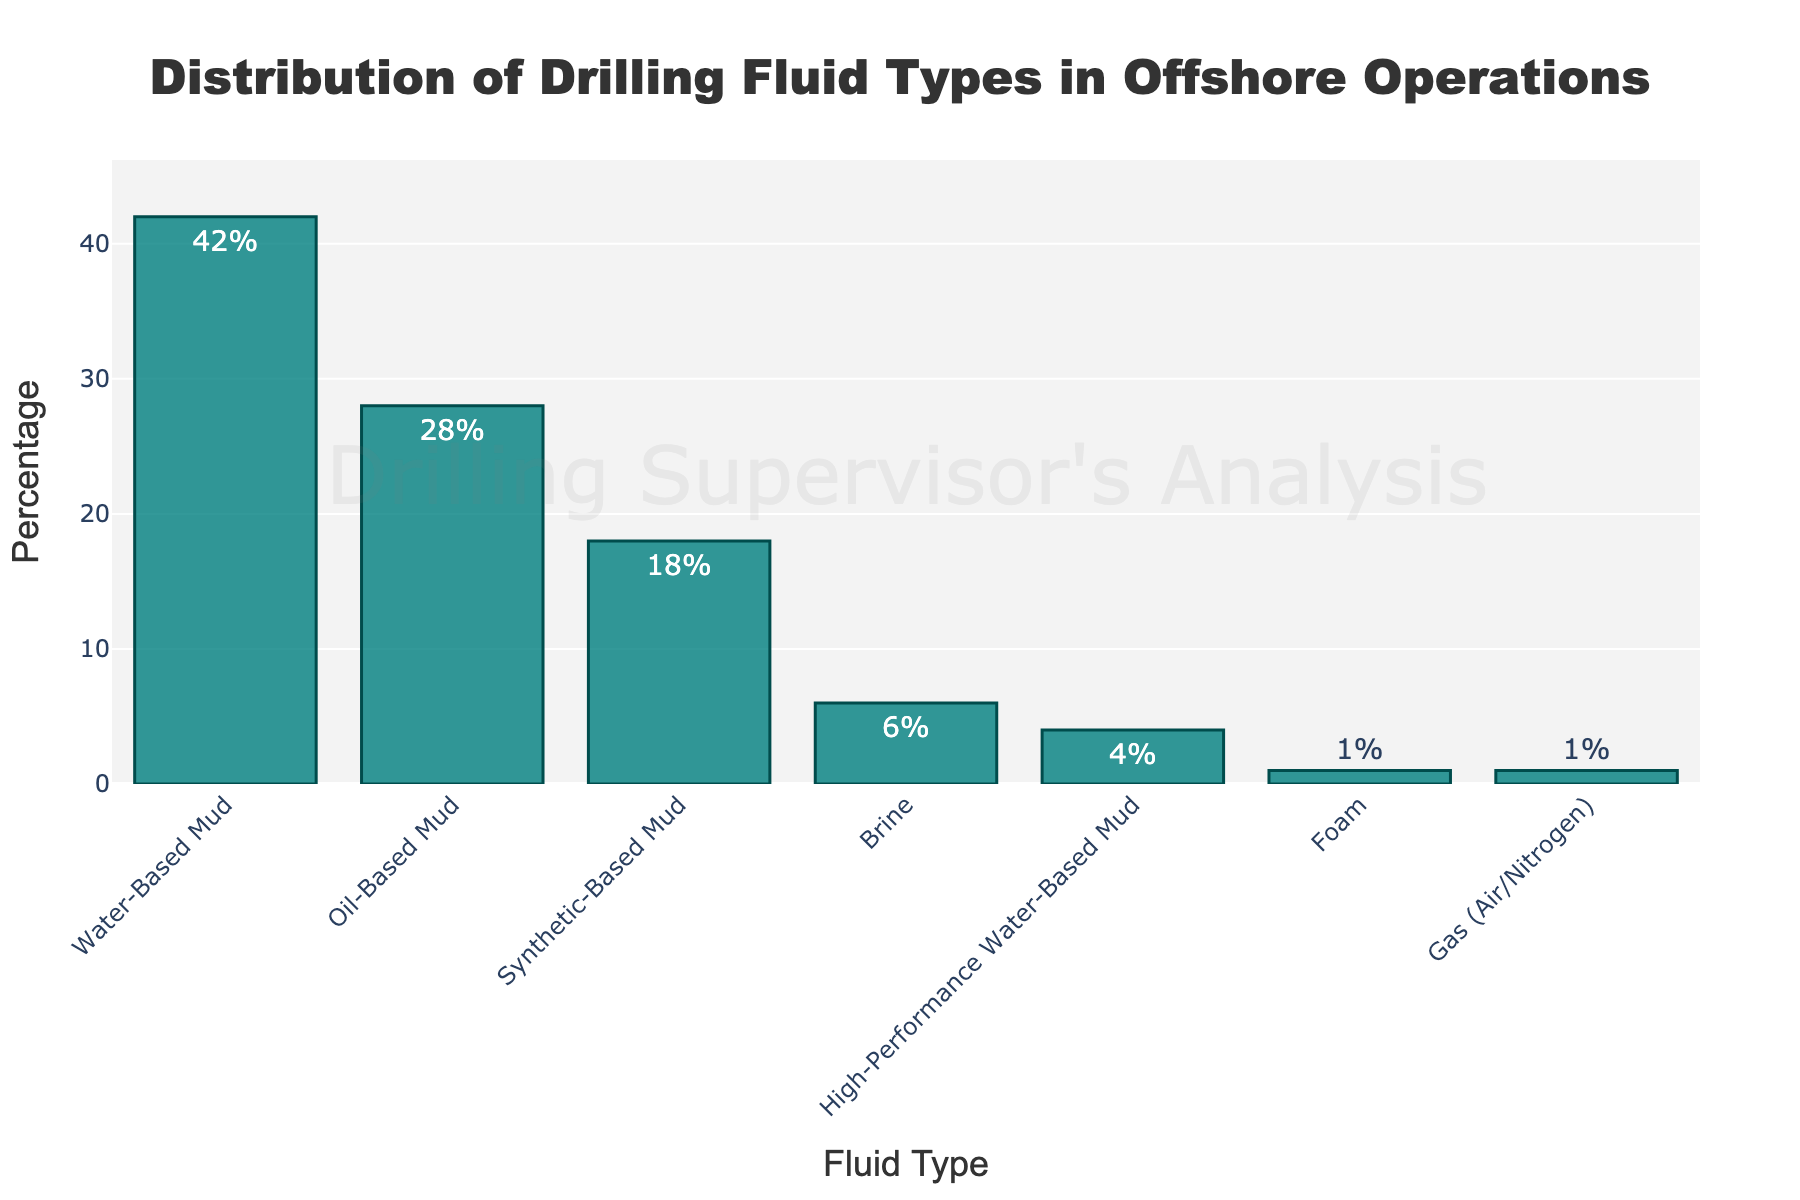What percentage of the fluids used are water-based? By looking at the "Water-Based Mud" bar, it represents 42%.
Answer: 42% What is the difference in percentage between oil-based and synthetic-based muds? The percentage for oil-based muds is 28%, and for synthetic-based muds, it is 18%. The difference between them is 28% - 18% = 10%.
Answer: 10% Which fluid type is used the least in offshore operations? The "Foam" and "Gas (Air/Nitrogen)" bars are the shortest, both at 1%.
Answer: Foam and Gas (Air/Nitrogen) What is the combined percentage of water-based and high-performance water-based muds? The percentage for water-based muds is 42% and for high-performance water-based muds it is 4%. Their combined percentage is 42% + 4% = 46%.
Answer: 46% How does the percentage of brine compare to that of oil-based mud? The percentage of brine is 6% compared to 28% for oil-based mud. Therefore, brine is used much less than oil-based mud.
Answer: Less than What is the sum of the percentages of all fluid types used? Sum all the given percentages: 42 + 28 + 18 + 6 + 4 + 1 + 1 = 100%.
Answer: 100% Which fluid type has the median percentage value? The fluid types sorted by percentage are: Gas (Air/Nitrogen) = 1%, Foam = 1%, High-Performance Water-Based Mud = 4%, Brine = 6%, Synthetic-Based Mud = 18%, Oil-Based Mud = 28%, Water-Based Mud = 42%. With 7 values, the median is the 4th value: Brine = 6%.
Answer: Brine What fluid type is used more, brine or synthetic-based mud? The percentage for synthetic-based mud is 18% and for brine, it is 6%. Synthetic-based mud is used more.
Answer: Synthetic-Based Mud What is the average percentage of the top three most used fluid types? The top three fluid types are water-based mud (42%), oil-based mud (28%), and synthetic-based mud (18%). Their average is (42 + 28 + 18) / 3 = 88 / 3 ≈ 29.33%.
Answer: 29.33% What is the approximate percentage represented by non-water-based muds? Percentage of total water-based muds (water-based + high-performance water-based) is 42% + 4% = 46%. Therefore, non-water-based muds represent 100% - 46% = 54%.
Answer: 54% 